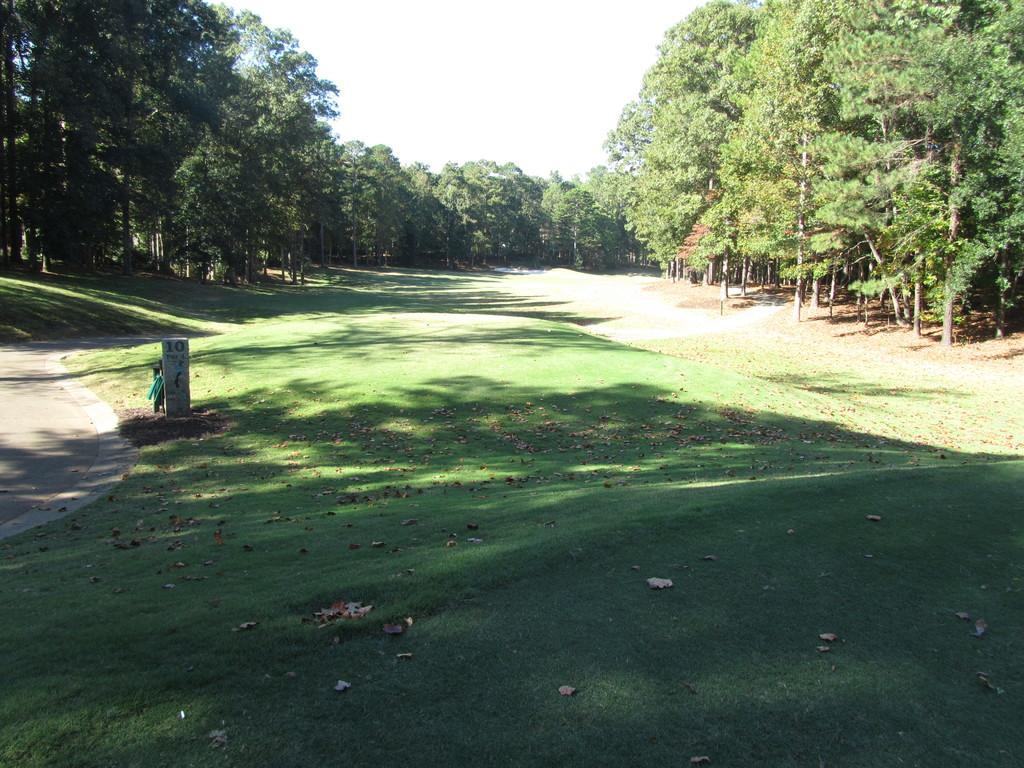What type of ground cover can be seen in the image? There is green grass on the ground in the image. What is the grass surrounded by? The grass is surrounded by trees. How would you describe the sky in the image? The sky is bright in the image. Can you see any details of the monkey sitting on the grass in the image? There is no monkey present in the image. What type of beef is being served on the grass in the image? There is no beef present in the image; it features green grass surrounded by trees and a bright sky. 